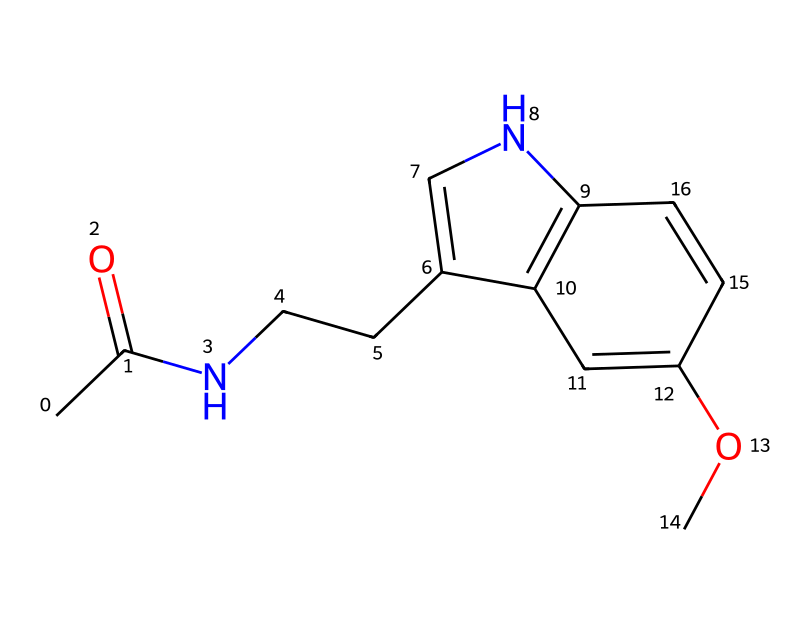What is the molecular formula of this compound? By analyzing the given SMILES notation, we can count the carbon (C), hydrogen (H), nitrogen (N), and oxygen (O) atoms present. The molecular formula can be derived, which in this case is C12H13N3O2.
Answer: C12H13N3O2 How many rings are present in the structure? The structure contains two distinct ring systems that can be identified from the connections within the SMILES string. Each cycle visible in the drawing counts as one ring, leading to a total of two rings.
Answer: 2 What type of nitrogen atoms are present in this compound? In the SMILES representation, nitrogen appears to be part of a five-membered ring. Knowing that it’s part of a heterocyclic component indicates that the nitrogen is likely in an aromatic state, typically seen in compounds like indoles. Therefore, they are classified as aromatic nitrogen atoms.
Answer: aromatic How does this compound potentially affect sleep patterns? The presence of indole-derived structures, as found in melatonin, allows it to interact with melatonin receptors in the brain. It is associated with regulating circadian rhythms, which can influence sleep-wake cycles, making it effective for improving sleep quality.
Answer: regulates circadian rhythms What role does the methoxy group play in the function of this compound? The methoxy (–OCH3) group enhances the lipophilicity of the molecule, facilitating its passage through biological membranes. This structural feature is integral in its effectiveness as a neurohormone, affecting its ability to bind with specific receptors related to sleep regulation.
Answer: enhances bioavailability Which type of bonds predominantly connects the atoms in this compound? Considering the molecular structure delves into both single and double bonds. However, the presence of carbon-carbon double bonds indicates that this compound contains covalent bonds as the main bonding type, characteristic of organic compounds.
Answer: covalent bonds 